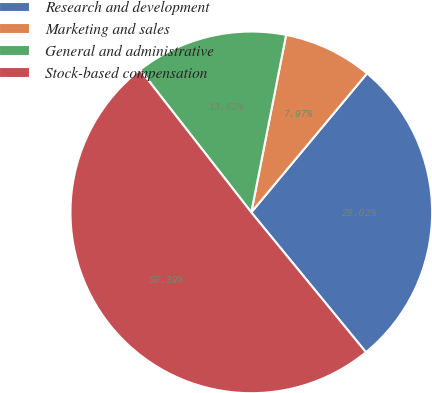Convert chart to OTSL. <chart><loc_0><loc_0><loc_500><loc_500><pie_chart><fcel>Research and development<fcel>Marketing and sales<fcel>General and administrative<fcel>Stock-based compensation<nl><fcel>28.02%<fcel>7.97%<fcel>13.62%<fcel>50.39%<nl></chart> 